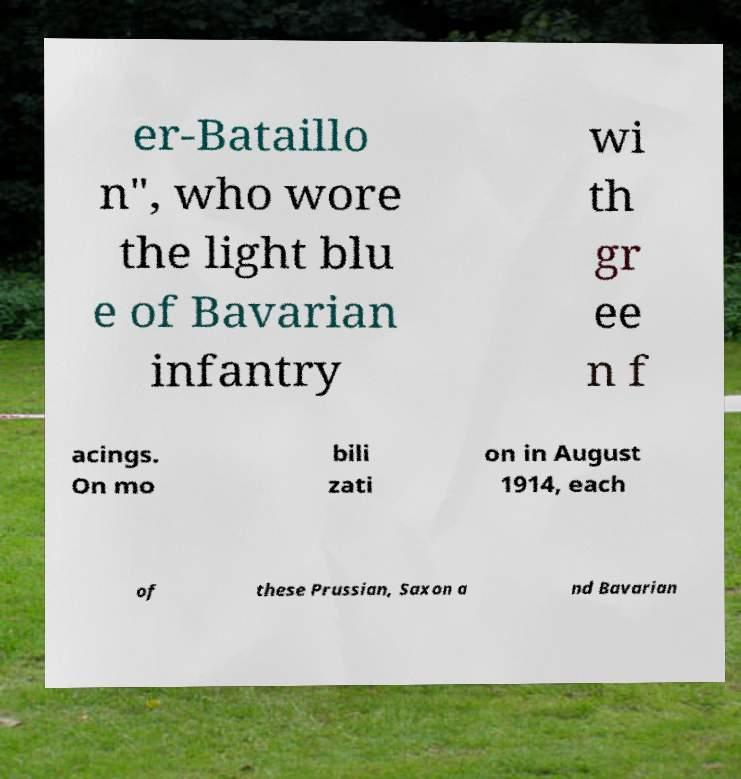Please identify and transcribe the text found in this image. er-Bataillo n", who wore the light blu e of Bavarian infantry wi th gr ee n f acings. On mo bili zati on in August 1914, each of these Prussian, Saxon a nd Bavarian 